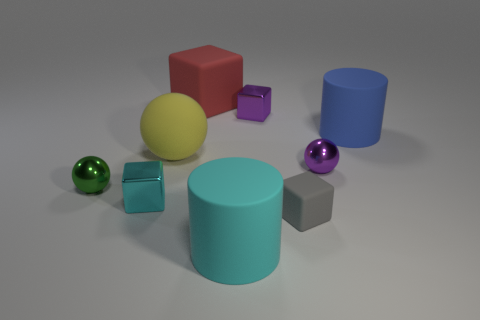Subtract all tiny purple shiny spheres. How many spheres are left? 2 Subtract all gray cubes. How many cubes are left? 3 Subtract 1 balls. How many balls are left? 2 Add 1 red matte cubes. How many objects exist? 10 Subtract all yellow blocks. Subtract all yellow cylinders. How many blocks are left? 4 Subtract all blocks. How many objects are left? 5 Subtract all small cyan matte spheres. Subtract all large yellow balls. How many objects are left? 8 Add 2 gray matte things. How many gray matte things are left? 3 Add 4 small purple metallic cubes. How many small purple metallic cubes exist? 5 Subtract 0 yellow cubes. How many objects are left? 9 